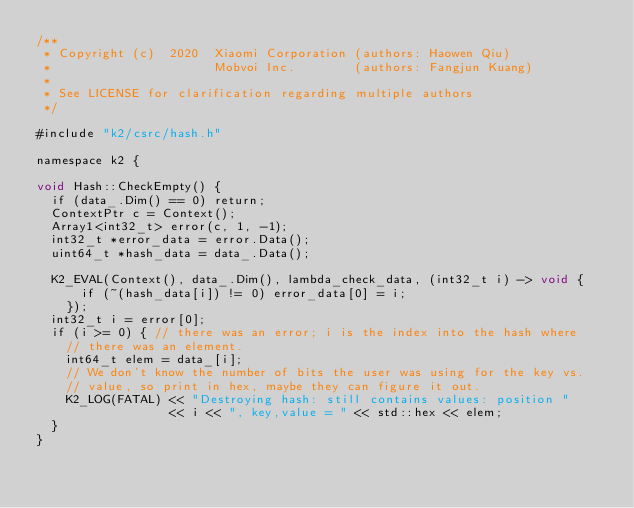<code> <loc_0><loc_0><loc_500><loc_500><_Cuda_>/**
 * Copyright (c)  2020  Xiaomi Corporation (authors: Haowen Qiu)
 *                      Mobvoi Inc.        (authors: Fangjun Kuang)
 *
 * See LICENSE for clarification regarding multiple authors
 */

#include "k2/csrc/hash.h"

namespace k2 {

void Hash::CheckEmpty() {
  if (data_.Dim() == 0) return;
  ContextPtr c = Context();
  Array1<int32_t> error(c, 1, -1);
  int32_t *error_data = error.Data();
  uint64_t *hash_data = data_.Data();

  K2_EVAL(Context(), data_.Dim(), lambda_check_data, (int32_t i) -> void {
      if (~(hash_data[i]) != 0) error_data[0] = i;
    });
  int32_t i = error[0];
  if (i >= 0) { // there was an error; i is the index into the hash where
    // there was an element.
    int64_t elem = data_[i];
    // We don't know the number of bits the user was using for the key vs.
    // value, so print in hex, maybe they can figure it out.
    K2_LOG(FATAL) << "Destroying hash: still contains values: position "
                  << i << ", key,value = " << std::hex << elem;
  }
}
</code> 